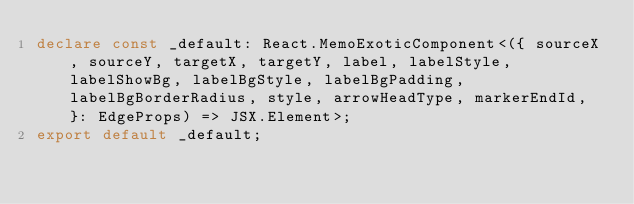Convert code to text. <code><loc_0><loc_0><loc_500><loc_500><_TypeScript_>declare const _default: React.MemoExoticComponent<({ sourceX, sourceY, targetX, targetY, label, labelStyle, labelShowBg, labelBgStyle, labelBgPadding, labelBgBorderRadius, style, arrowHeadType, markerEndId, }: EdgeProps) => JSX.Element>;
export default _default;
</code> 